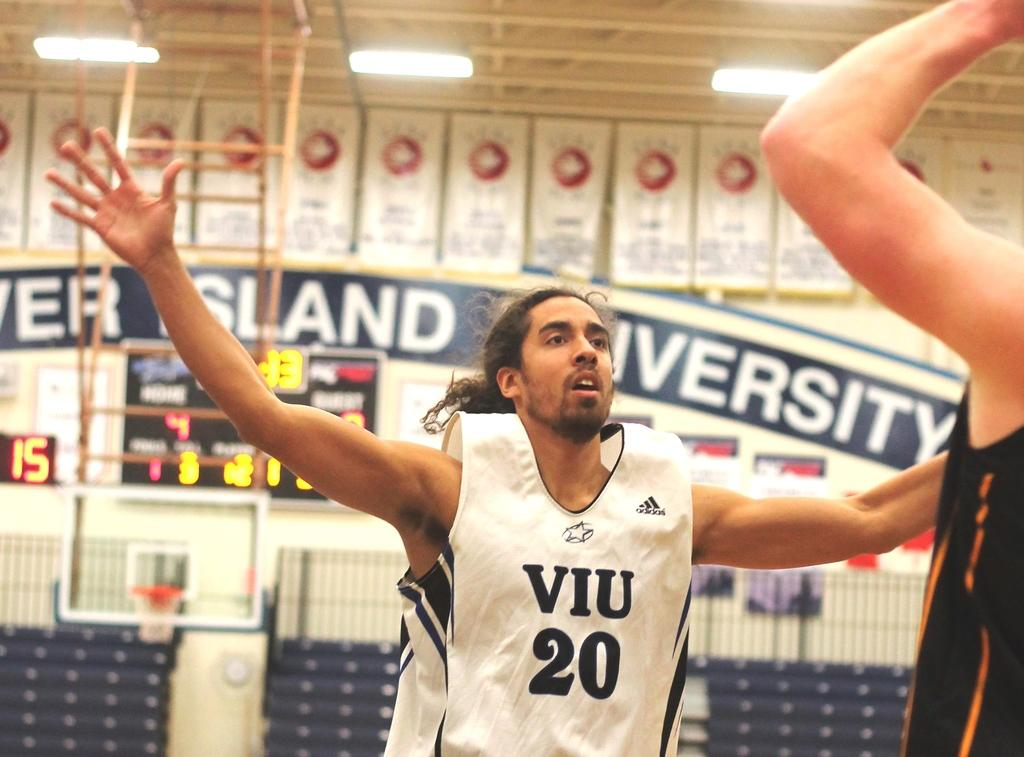How many people are present in the image? There are two people in the image. What are the people doing in the image? The people are on a path. What can be seen in the background of the image? There is a scoreboard and a wall in the background of the image. What type of lighting is visible in the image? There are ceiling lights visible in the image. What color is the cake that the beast is holding in the image? There is no cake or beast present in the image. 